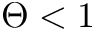Convert formula to latex. <formula><loc_0><loc_0><loc_500><loc_500>\Theta < 1</formula> 